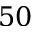<formula> <loc_0><loc_0><loc_500><loc_500>5 0</formula> 